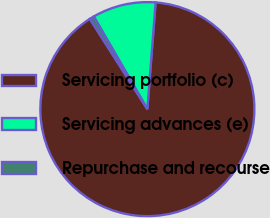Convert chart. <chart><loc_0><loc_0><loc_500><loc_500><pie_chart><fcel>Servicing portfolio (c)<fcel>Servicing advances (e)<fcel>Repurchase and recourse<nl><fcel>89.74%<fcel>9.58%<fcel>0.68%<nl></chart> 